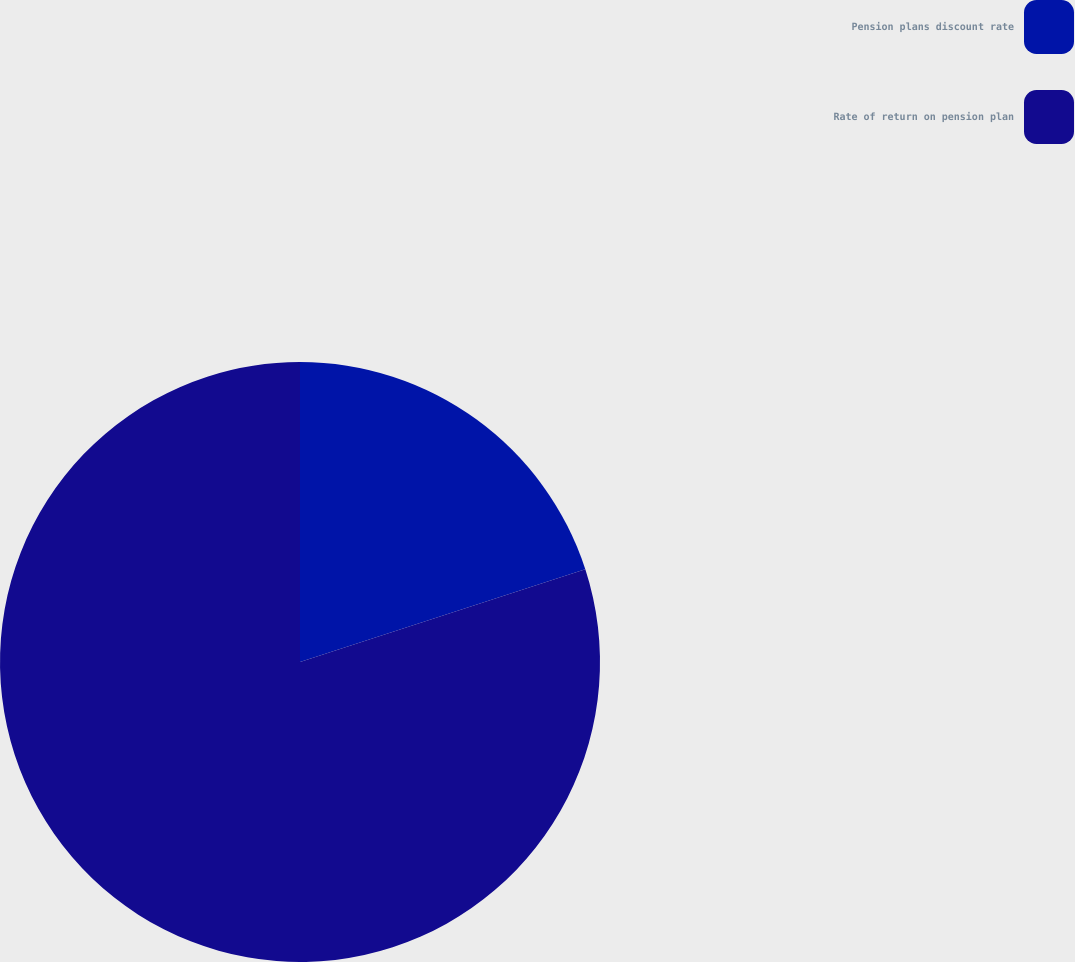Convert chart. <chart><loc_0><loc_0><loc_500><loc_500><pie_chart><fcel>Pension plans discount rate<fcel>Rate of return on pension plan<nl><fcel>20.0%<fcel>80.0%<nl></chart> 